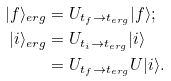Convert formula to latex. <formula><loc_0><loc_0><loc_500><loc_500>| f \rangle _ { e r g } & = U _ { t _ { f } \to t _ { e r g } } | f \rangle ; \\ | i \rangle _ { e r g } & = U _ { t _ { i } \to t _ { e r g } } | i \rangle \\ & = U _ { t _ { f } \to t _ { e r g } } U | i \rangle .</formula> 